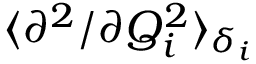<formula> <loc_0><loc_0><loc_500><loc_500>\langle { \partial ^ { 2 } } / { \partial Q _ { i } ^ { 2 } } \rangle _ { \delta _ { i } }</formula> 